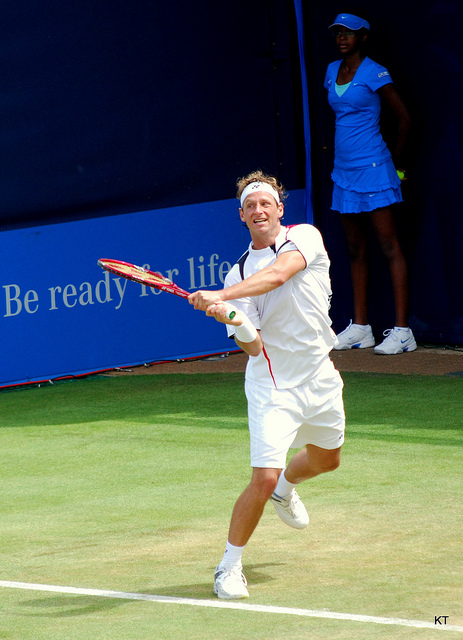Identify the text contained in this image. Be ready for life KT 